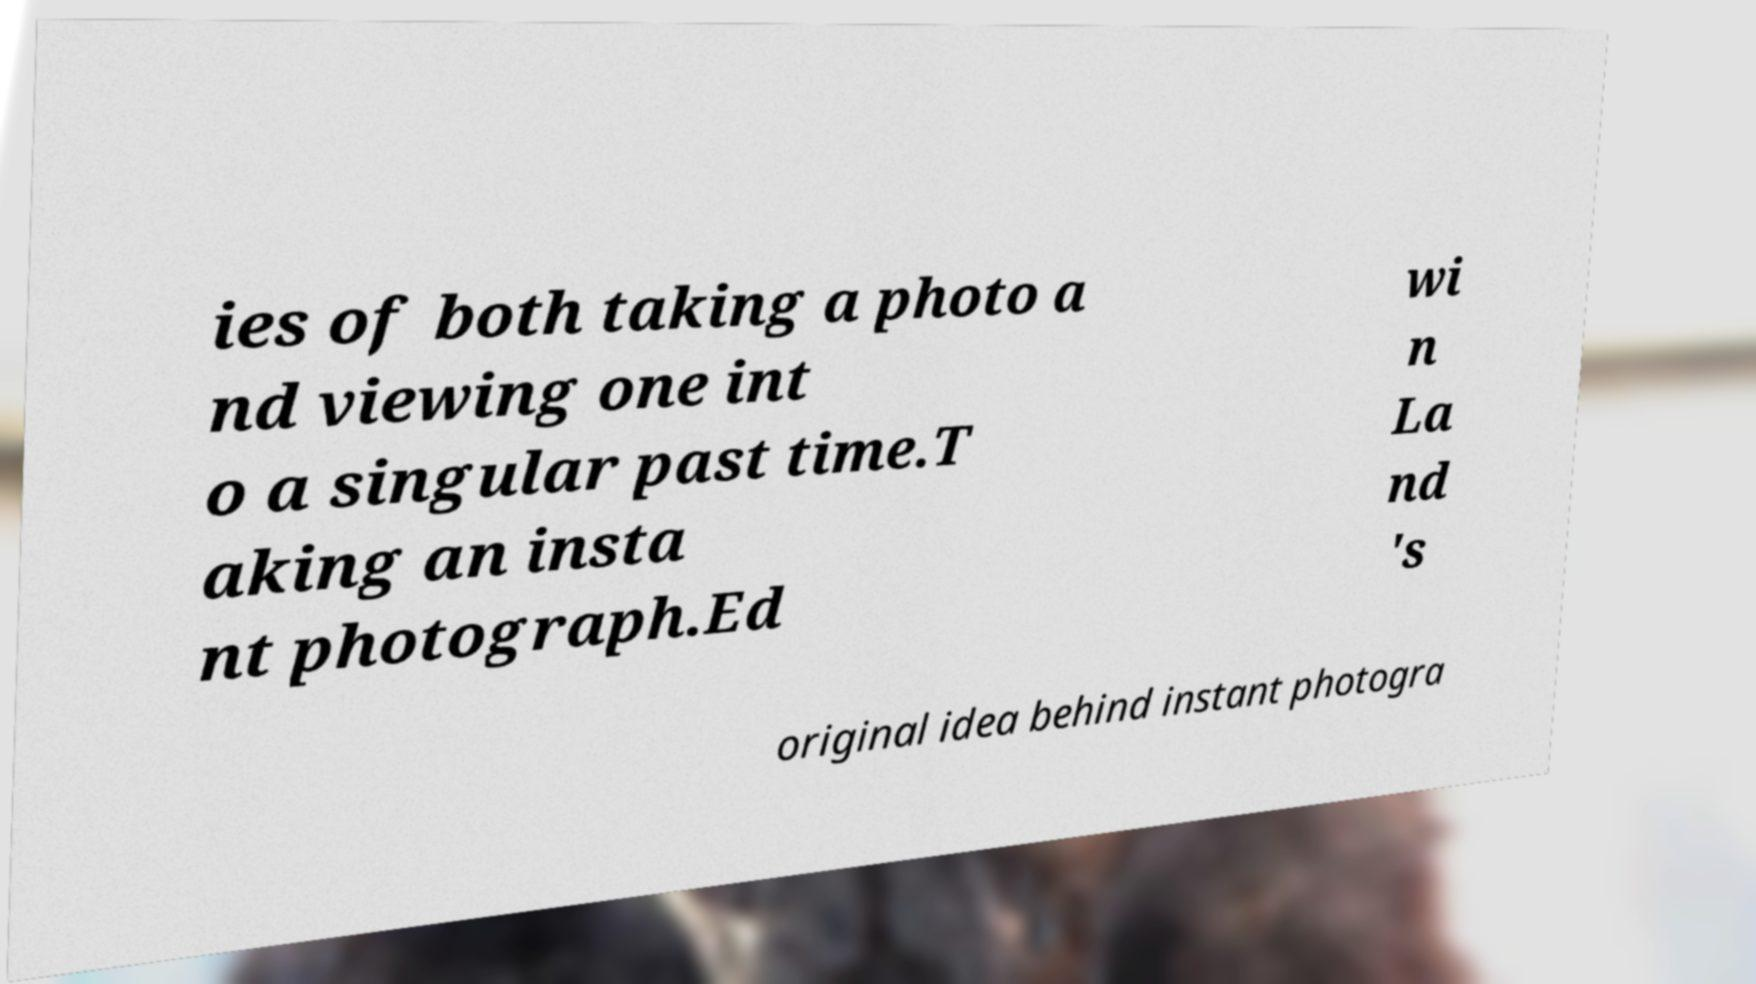Please read and relay the text visible in this image. What does it say? ies of both taking a photo a nd viewing one int o a singular past time.T aking an insta nt photograph.Ed wi n La nd 's original idea behind instant photogra 